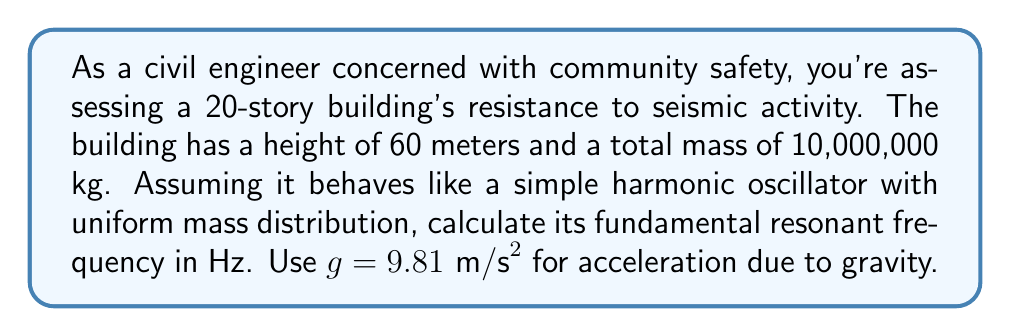Give your solution to this math problem. To solve this problem, we'll use the formula for the fundamental frequency of a uniform cantilever beam:

1) The formula for the fundamental frequency is:

   $$f = \frac{1}{2\pi}\sqrt{\frac{3EI}{mL^3}}$$

   Where:
   $f$ is the fundamental frequency in Hz
   $E$ is the Young's modulus
   $I$ is the moment of inertia
   $m$ is the mass per unit length
   $L$ is the height of the building

2) For a building modeled as a simple harmonic oscillator, we can simplify this to:

   $$f = \frac{1}{2\pi}\sqrt{\frac{k}{m}}$$

   Where $k$ is the effective stiffness of the building.

3) For a tall building, we can approximate $k$ as:

   $$k = \frac{3EI}{L^3}$$

4) Substituting this into our frequency equation:

   $$f = \frac{1}{2\pi}\sqrt{\frac{3EI}{mL^3}}$$

5) For a uniform mass distribution, $m = M/L$, where $M$ is the total mass. Substituting:

   $$f = \frac{1}{2\pi}\sqrt{\frac{3EI}{M/L \cdot L^3}} = \frac{1}{2\pi}\sqrt{\frac{3EIL}{ML^3}}$$

6) For tall buildings, it's often approximated that:

   $$\frac{3EI}{L^3} \approx \frac{M}{L}g$$

7) Substituting this into our equation:

   $$f = \frac{1}{2\pi}\sqrt{\frac{Mg}{ML}} = \frac{1}{2\pi}\sqrt{\frac{g}{L}}$$

8) Now we can plug in our values:
   $g = 9.81 \text{ m/s}^2$
   $L = 60 \text{ m}$

   $$f = \frac{1}{2\pi}\sqrt{\frac{9.81}{60}} \approx 0.2036 \text{ Hz}$$

Thus, the fundamental resonant frequency of the building is approximately 0.2036 Hz.
Answer: 0.2036 Hz 